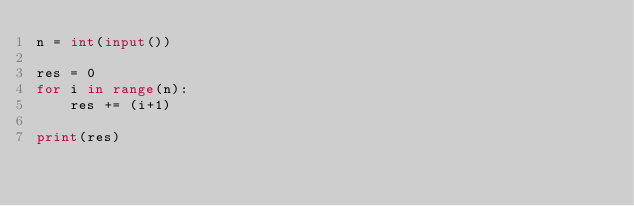Convert code to text. <code><loc_0><loc_0><loc_500><loc_500><_Python_>n = int(input())

res = 0
for i in range(n):
    res += (i+1)

print(res)</code> 